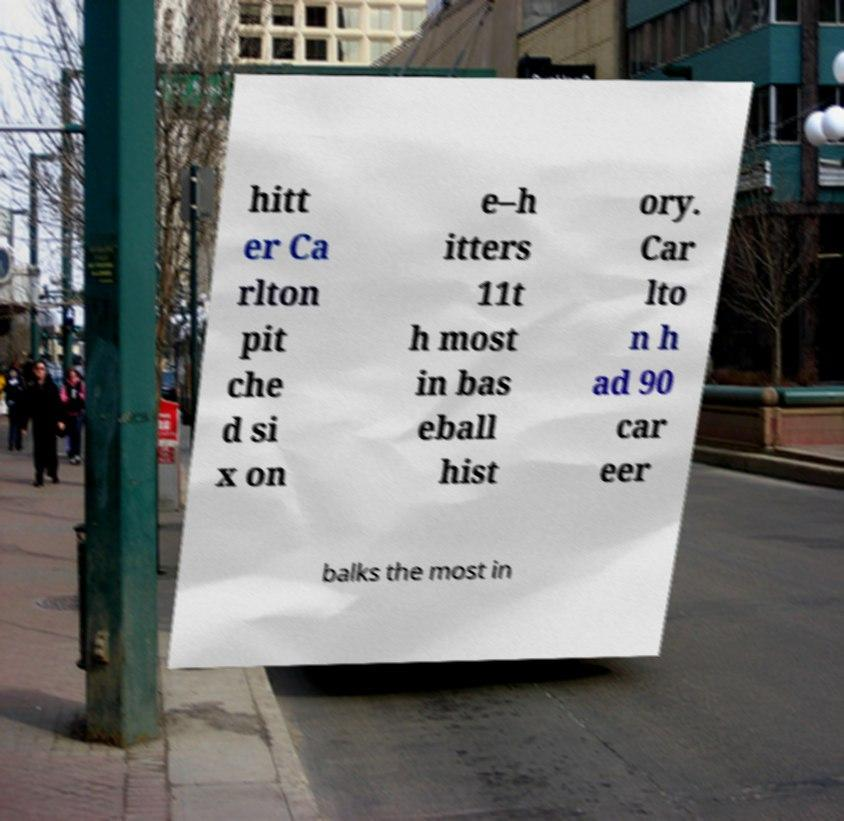I need the written content from this picture converted into text. Can you do that? hitt er Ca rlton pit che d si x on e–h itters 11t h most in bas eball hist ory. Car lto n h ad 90 car eer balks the most in 